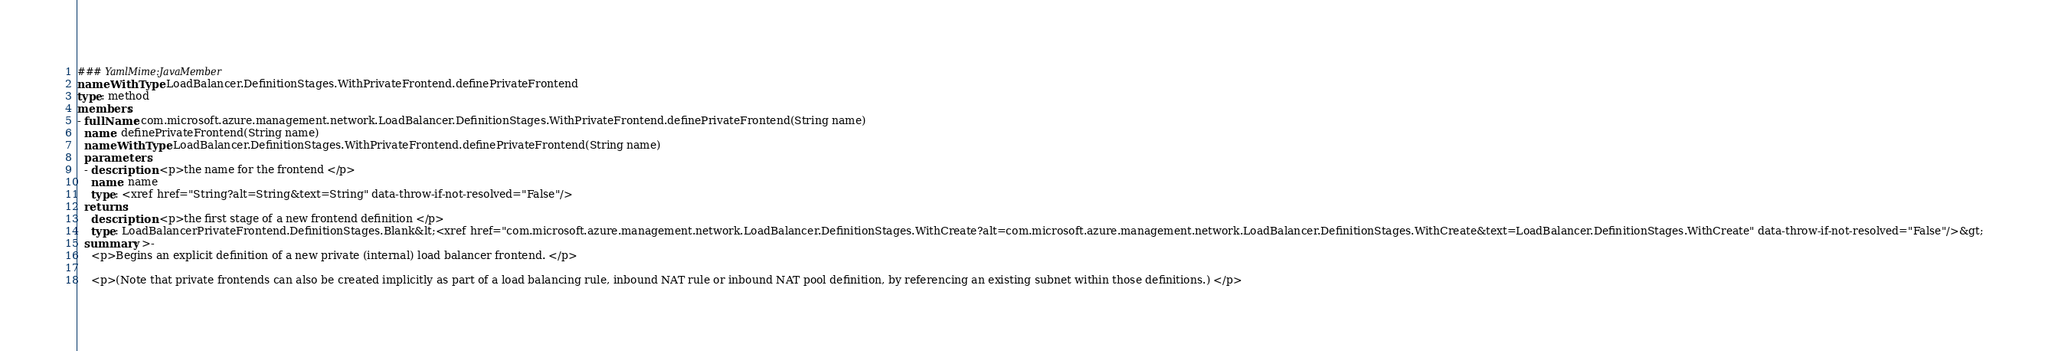<code> <loc_0><loc_0><loc_500><loc_500><_YAML_>### YamlMime:JavaMember
nameWithType: LoadBalancer.DefinitionStages.WithPrivateFrontend.definePrivateFrontend
type: method
members:
- fullName: com.microsoft.azure.management.network.LoadBalancer.DefinitionStages.WithPrivateFrontend.definePrivateFrontend(String name)
  name: definePrivateFrontend(String name)
  nameWithType: LoadBalancer.DefinitionStages.WithPrivateFrontend.definePrivateFrontend(String name)
  parameters:
  - description: <p>the name for the frontend </p>
    name: name
    type: <xref href="String?alt=String&text=String" data-throw-if-not-resolved="False"/>
  returns:
    description: <p>the first stage of a new frontend definition </p>
    type: LoadBalancerPrivateFrontend.DefinitionStages.Blank&lt;<xref href="com.microsoft.azure.management.network.LoadBalancer.DefinitionStages.WithCreate?alt=com.microsoft.azure.management.network.LoadBalancer.DefinitionStages.WithCreate&text=LoadBalancer.DefinitionStages.WithCreate" data-throw-if-not-resolved="False"/>&gt;
  summary: >-
    <p>Begins an explicit definition of a new private (internal) load balancer frontend. </p>

    <p>(Note that private frontends can also be created implicitly as part of a load balancing rule, inbound NAT rule or inbound NAT pool definition, by referencing an existing subnet within those definitions.) </p></code> 